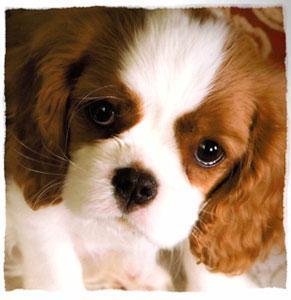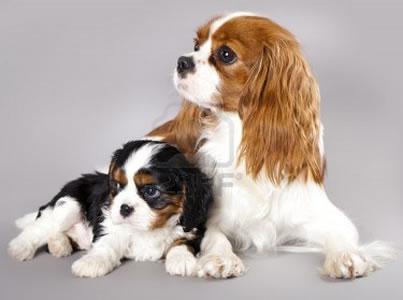The first image is the image on the left, the second image is the image on the right. Analyze the images presented: Is the assertion "There are three dogs" valid? Answer yes or no. Yes. 